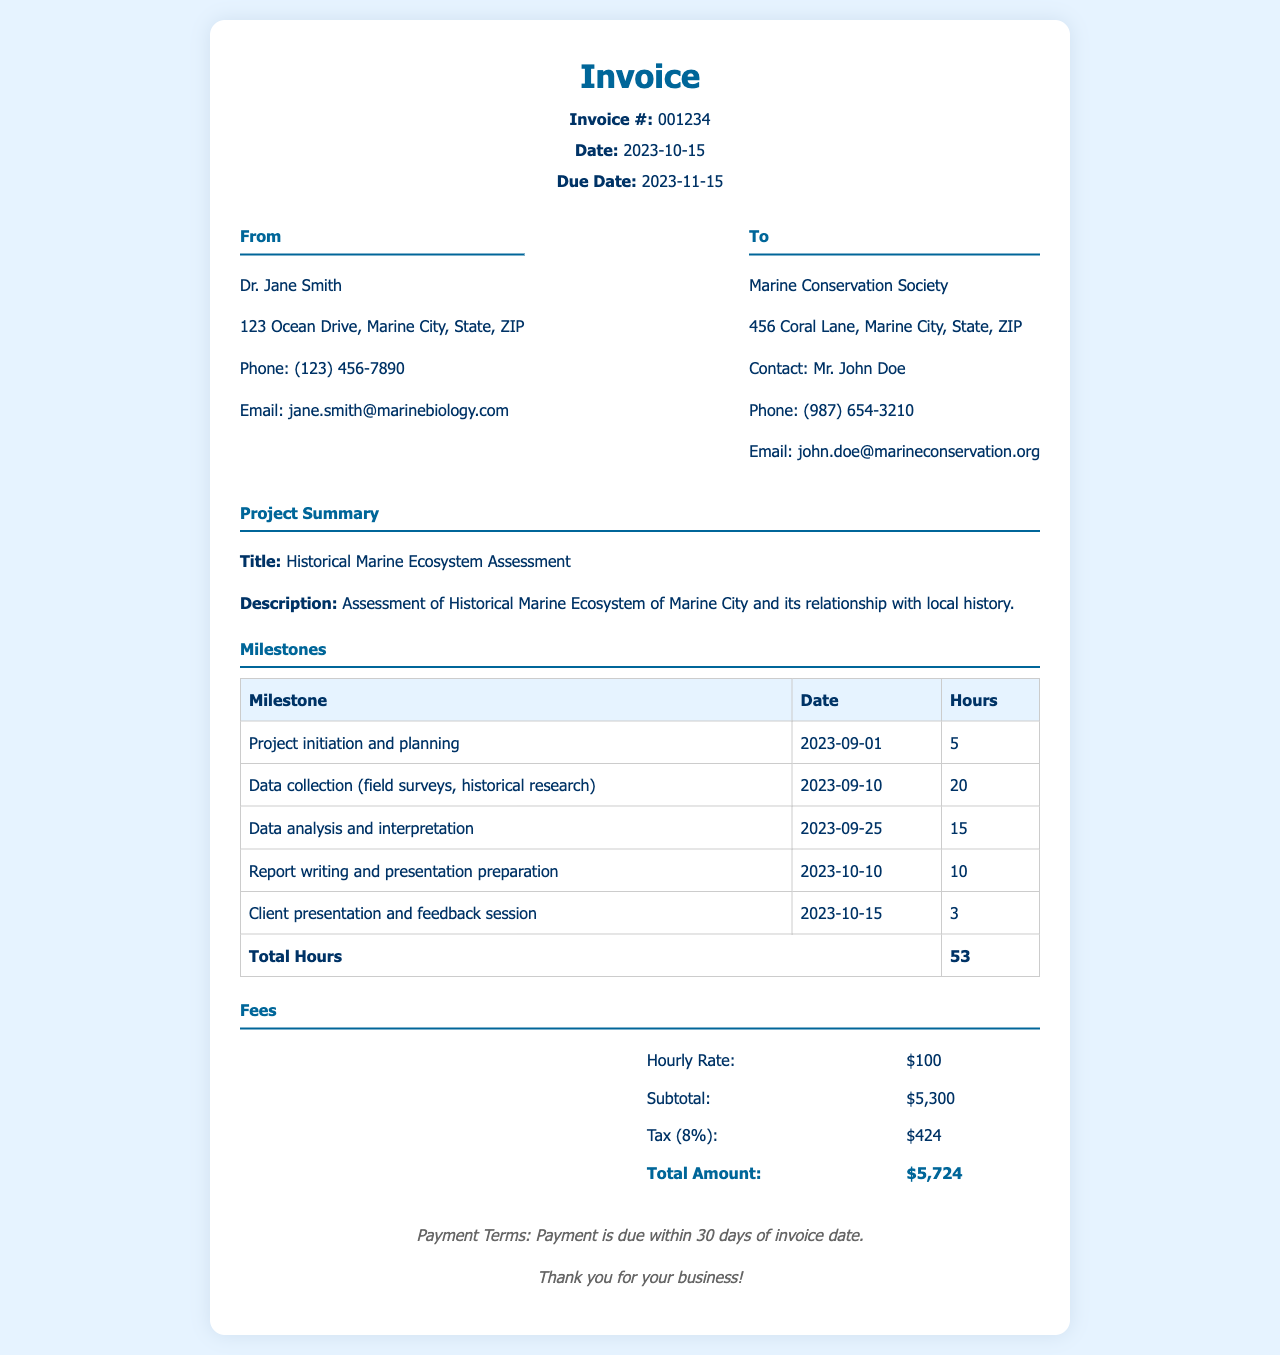what is the invoice number? The invoice number is a unique identifier listed in the header section of the document.
Answer: 001234 what is the due date of the invoice? The due date is the deadline by which the payment must be made, found in the header section.
Answer: 2023-11-15 how many hours were worked in total? The total hours worked is the sum of hours for all milestones provided in the milestones table.
Answer: 53 who is the consultant for this project? The consultant's name is mentioned in the "From" section of the invoice.
Answer: Dr. Jane Smith what is the hourly rate charged? The hourly rate is clearly stated in the fees section of the invoice.
Answer: $100 what was the project completion date for report writing? The project completion date for the report writing milestone is listed in the milestones table.
Answer: 2023-10-10 what is the subtotal amount before tax? The subtotal amount is shown in the fees section before any tax is applied.
Answer: $5,300 who is to be billed for the service? The billing information is provided in the "To" section of the invoice, indicating the client being billed.
Answer: Marine Conservation Society what percentage is the tax applied on the subtotal? The tax percentage is indicated in the fees section as a specific value applied to the subtotal.
Answer: 8% 